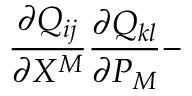Convert formula to latex. <formula><loc_0><loc_0><loc_500><loc_500>\frac { \partial Q _ { i j } } { \partial X ^ { M } } \frac { \partial Q _ { k l } } { \partial P _ { M } } -</formula> 